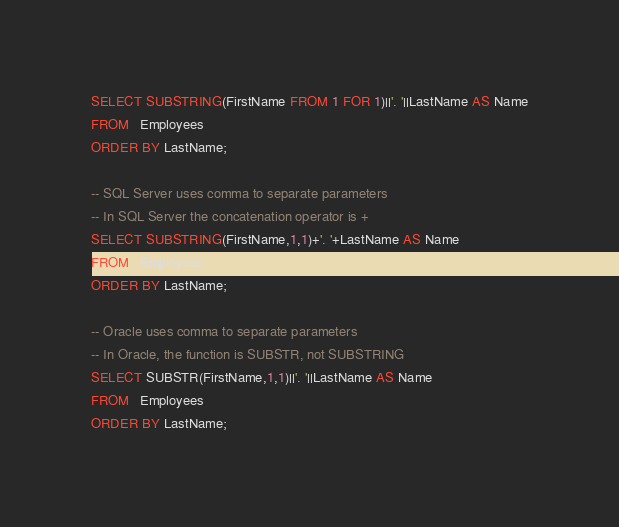Convert code to text. <code><loc_0><loc_0><loc_500><loc_500><_SQL_>SELECT SUBSTRING(FirstName FROM 1 FOR 1)||'. '||LastName AS Name
FROM   Employees
ORDER BY LastName;

-- SQL Server uses comma to separate parameters
-- In SQL Server the concatenation operator is +
SELECT SUBSTRING(FirstName,1,1)+'. '+LastName AS Name
FROM   Employees
ORDER BY LastName;

-- Oracle uses comma to separate parameters
-- In Oracle, the function is SUBSTR, not SUBSTRING
SELECT SUBSTR(FirstName,1,1)||'. '||LastName AS Name
FROM   Employees
ORDER BY LastName;

</code> 